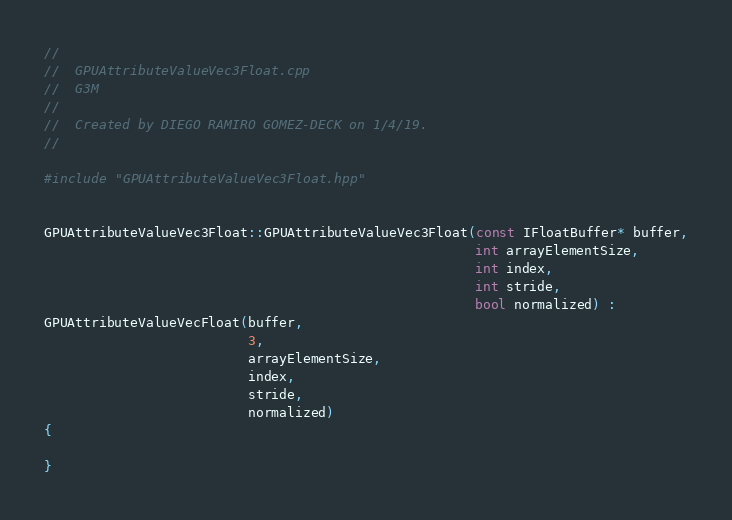Convert code to text. <code><loc_0><loc_0><loc_500><loc_500><_C++_>//
//  GPUAttributeValueVec3Float.cpp
//  G3M
//
//  Created by DIEGO RAMIRO GOMEZ-DECK on 1/4/19.
//

#include "GPUAttributeValueVec3Float.hpp"


GPUAttributeValueVec3Float::GPUAttributeValueVec3Float(const IFloatBuffer* buffer,
                                                       int arrayElementSize,
                                                       int index,
                                                       int stride,
                                                       bool normalized) :
GPUAttributeValueVecFloat(buffer,
                          3,
                          arrayElementSize,
                          index,
                          stride,
                          normalized)
{

}
</code> 